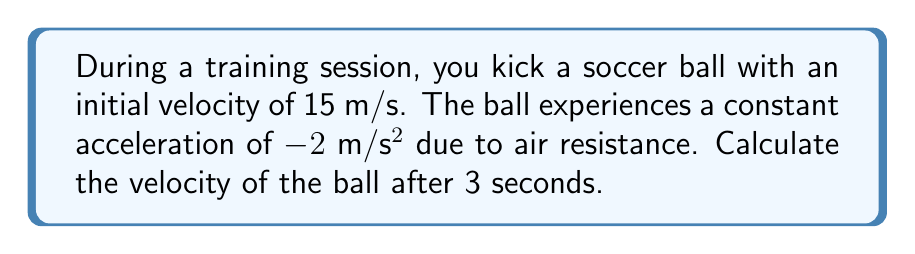Provide a solution to this math problem. To solve this problem, we'll use the equation for velocity under constant acceleration:

$$v = v_0 + at$$

Where:
$v$ = final velocity
$v_0$ = initial velocity
$a$ = acceleration
$t$ = time

Given:
$v_0 = 15$ m/s
$a = -2$ m/s²
$t = 3$ s

Let's substitute these values into the equation:

$$v = 15 + (-2)(3)$$

Simplifying:
$$v = 15 - 6$$
$$v = 9$$

Therefore, after 3 seconds, the velocity of the soccer ball will be 9 m/s.

This calculation is useful for a soccer coach to understand how the ball's speed changes during play, which can inform strategies for passing and shooting drills.
Answer: $v = 9$ m/s 